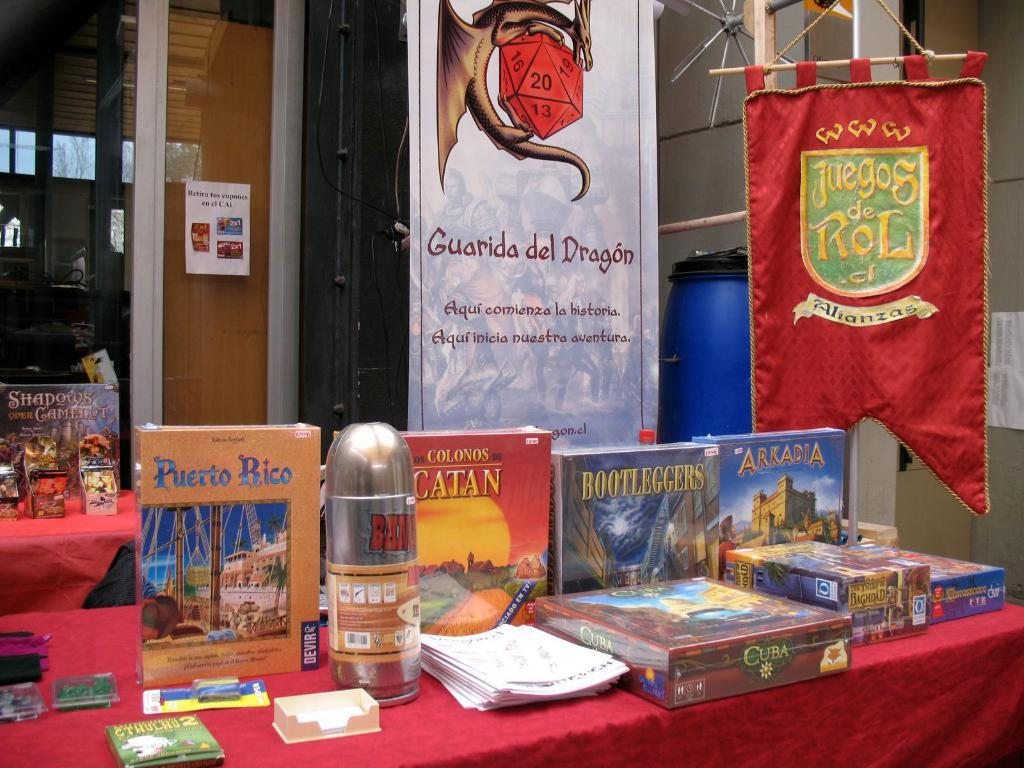Provide a one-sentence caption for the provided image. One on the books on the table is titled Bootleggers. 